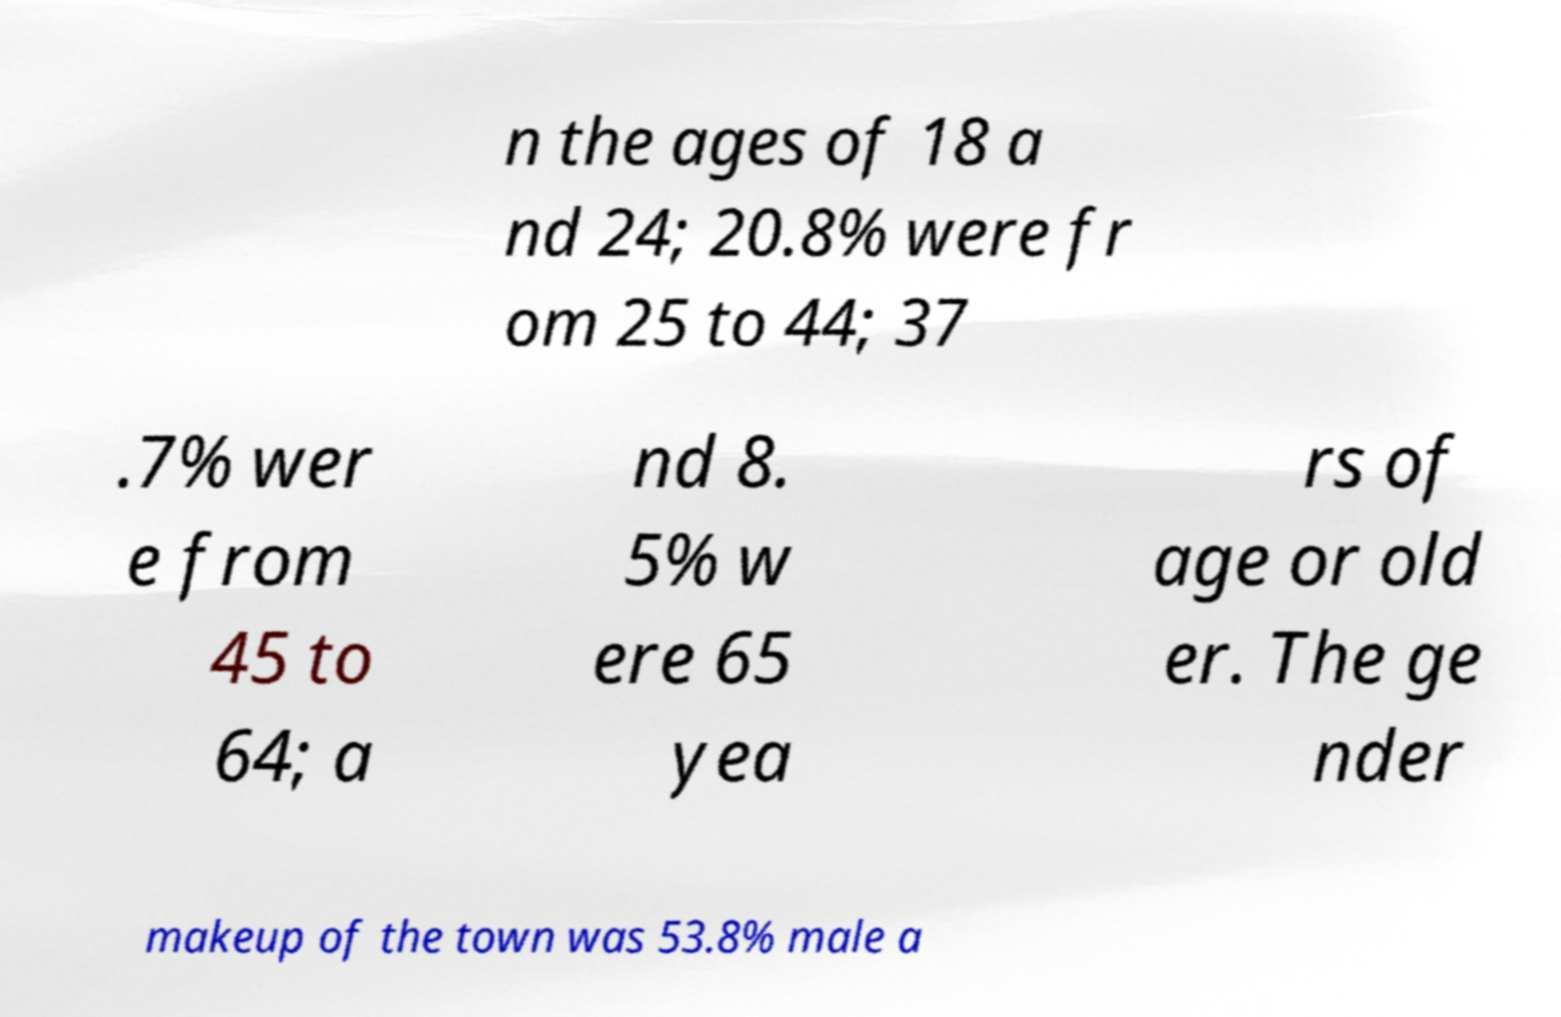There's text embedded in this image that I need extracted. Can you transcribe it verbatim? n the ages of 18 a nd 24; 20.8% were fr om 25 to 44; 37 .7% wer e from 45 to 64; a nd 8. 5% w ere 65 yea rs of age or old er. The ge nder makeup of the town was 53.8% male a 